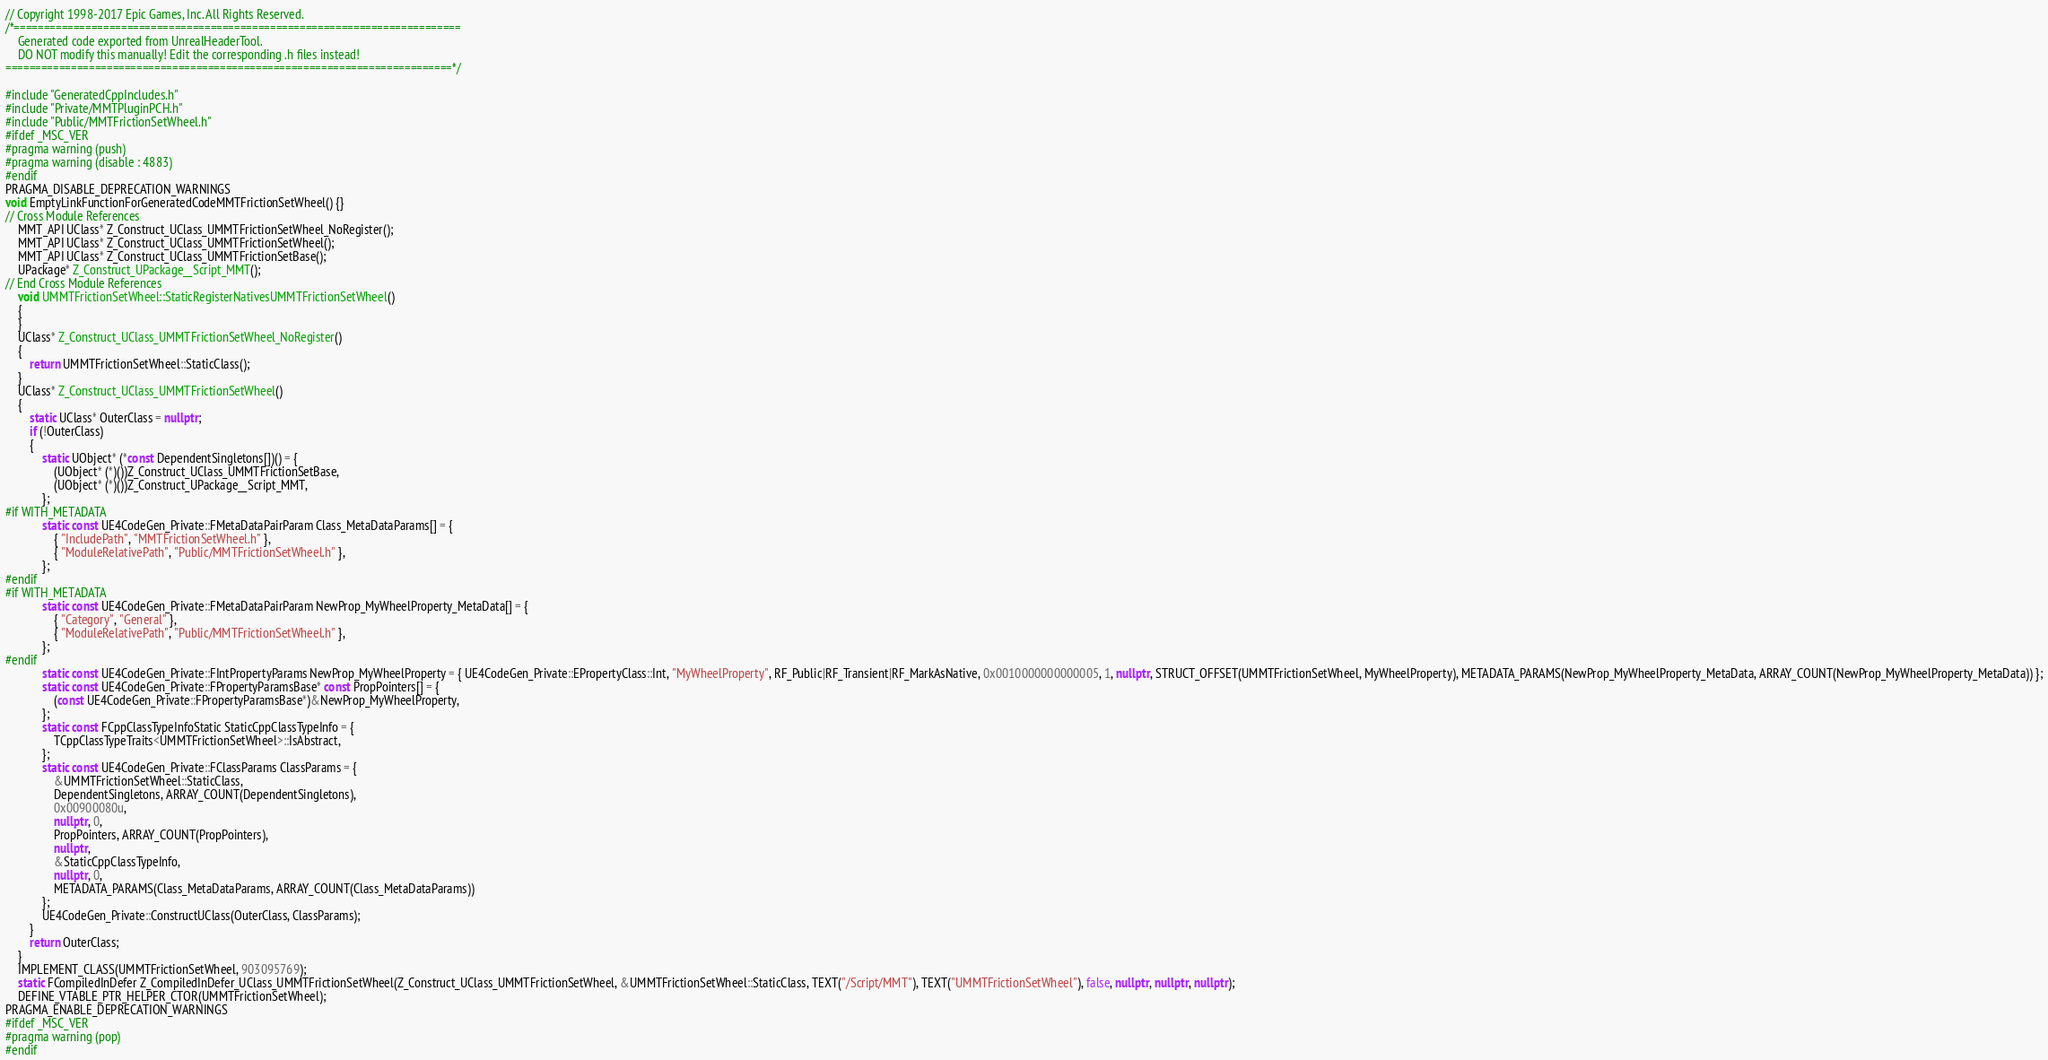<code> <loc_0><loc_0><loc_500><loc_500><_C++_>// Copyright 1998-2017 Epic Games, Inc. All Rights Reserved.
/*===========================================================================
	Generated code exported from UnrealHeaderTool.
	DO NOT modify this manually! Edit the corresponding .h files instead!
===========================================================================*/

#include "GeneratedCppIncludes.h"
#include "Private/MMTPluginPCH.h"
#include "Public/MMTFrictionSetWheel.h"
#ifdef _MSC_VER
#pragma warning (push)
#pragma warning (disable : 4883)
#endif
PRAGMA_DISABLE_DEPRECATION_WARNINGS
void EmptyLinkFunctionForGeneratedCodeMMTFrictionSetWheel() {}
// Cross Module References
	MMT_API UClass* Z_Construct_UClass_UMMTFrictionSetWheel_NoRegister();
	MMT_API UClass* Z_Construct_UClass_UMMTFrictionSetWheel();
	MMT_API UClass* Z_Construct_UClass_UMMTFrictionSetBase();
	UPackage* Z_Construct_UPackage__Script_MMT();
// End Cross Module References
	void UMMTFrictionSetWheel::StaticRegisterNativesUMMTFrictionSetWheel()
	{
	}
	UClass* Z_Construct_UClass_UMMTFrictionSetWheel_NoRegister()
	{
		return UMMTFrictionSetWheel::StaticClass();
	}
	UClass* Z_Construct_UClass_UMMTFrictionSetWheel()
	{
		static UClass* OuterClass = nullptr;
		if (!OuterClass)
		{
			static UObject* (*const DependentSingletons[])() = {
				(UObject* (*)())Z_Construct_UClass_UMMTFrictionSetBase,
				(UObject* (*)())Z_Construct_UPackage__Script_MMT,
			};
#if WITH_METADATA
			static const UE4CodeGen_Private::FMetaDataPairParam Class_MetaDataParams[] = {
				{ "IncludePath", "MMTFrictionSetWheel.h" },
				{ "ModuleRelativePath", "Public/MMTFrictionSetWheel.h" },
			};
#endif
#if WITH_METADATA
			static const UE4CodeGen_Private::FMetaDataPairParam NewProp_MyWheelProperty_MetaData[] = {
				{ "Category", "General" },
				{ "ModuleRelativePath", "Public/MMTFrictionSetWheel.h" },
			};
#endif
			static const UE4CodeGen_Private::FIntPropertyParams NewProp_MyWheelProperty = { UE4CodeGen_Private::EPropertyClass::Int, "MyWheelProperty", RF_Public|RF_Transient|RF_MarkAsNative, 0x0010000000000005, 1, nullptr, STRUCT_OFFSET(UMMTFrictionSetWheel, MyWheelProperty), METADATA_PARAMS(NewProp_MyWheelProperty_MetaData, ARRAY_COUNT(NewProp_MyWheelProperty_MetaData)) };
			static const UE4CodeGen_Private::FPropertyParamsBase* const PropPointers[] = {
				(const UE4CodeGen_Private::FPropertyParamsBase*)&NewProp_MyWheelProperty,
			};
			static const FCppClassTypeInfoStatic StaticCppClassTypeInfo = {
				TCppClassTypeTraits<UMMTFrictionSetWheel>::IsAbstract,
			};
			static const UE4CodeGen_Private::FClassParams ClassParams = {
				&UMMTFrictionSetWheel::StaticClass,
				DependentSingletons, ARRAY_COUNT(DependentSingletons),
				0x00900080u,
				nullptr, 0,
				PropPointers, ARRAY_COUNT(PropPointers),
				nullptr,
				&StaticCppClassTypeInfo,
				nullptr, 0,
				METADATA_PARAMS(Class_MetaDataParams, ARRAY_COUNT(Class_MetaDataParams))
			};
			UE4CodeGen_Private::ConstructUClass(OuterClass, ClassParams);
		}
		return OuterClass;
	}
	IMPLEMENT_CLASS(UMMTFrictionSetWheel, 903095769);
	static FCompiledInDefer Z_CompiledInDefer_UClass_UMMTFrictionSetWheel(Z_Construct_UClass_UMMTFrictionSetWheel, &UMMTFrictionSetWheel::StaticClass, TEXT("/Script/MMT"), TEXT("UMMTFrictionSetWheel"), false, nullptr, nullptr, nullptr);
	DEFINE_VTABLE_PTR_HELPER_CTOR(UMMTFrictionSetWheel);
PRAGMA_ENABLE_DEPRECATION_WARNINGS
#ifdef _MSC_VER
#pragma warning (pop)
#endif
</code> 